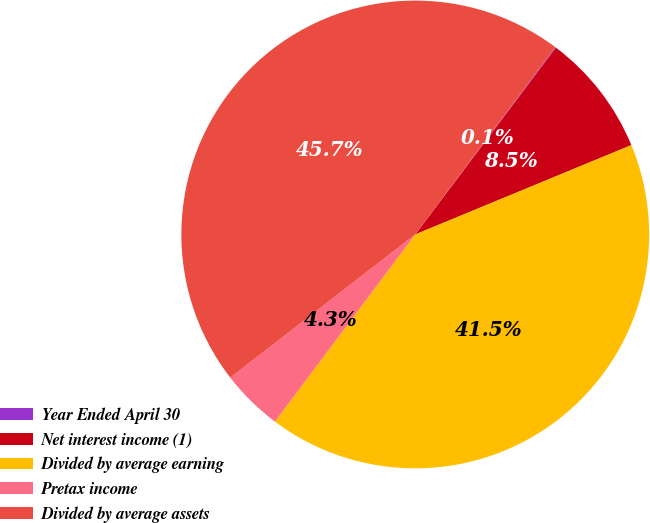Convert chart to OTSL. <chart><loc_0><loc_0><loc_500><loc_500><pie_chart><fcel>Year Ended April 30<fcel>Net interest income (1)<fcel>Divided by average earning<fcel>Pretax income<fcel>Divided by average assets<nl><fcel>0.06%<fcel>8.49%<fcel>41.48%<fcel>4.28%<fcel>45.7%<nl></chart> 